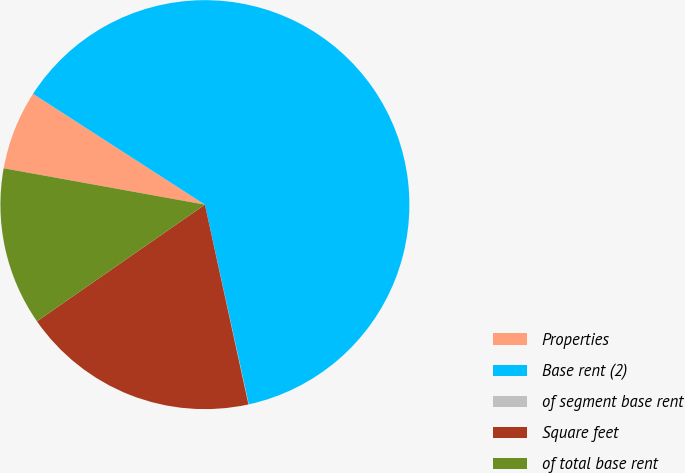Convert chart to OTSL. <chart><loc_0><loc_0><loc_500><loc_500><pie_chart><fcel>Properties<fcel>Base rent (2)<fcel>of segment base rent<fcel>Square feet<fcel>of total base rent<nl><fcel>6.27%<fcel>62.44%<fcel>0.03%<fcel>18.75%<fcel>12.51%<nl></chart> 